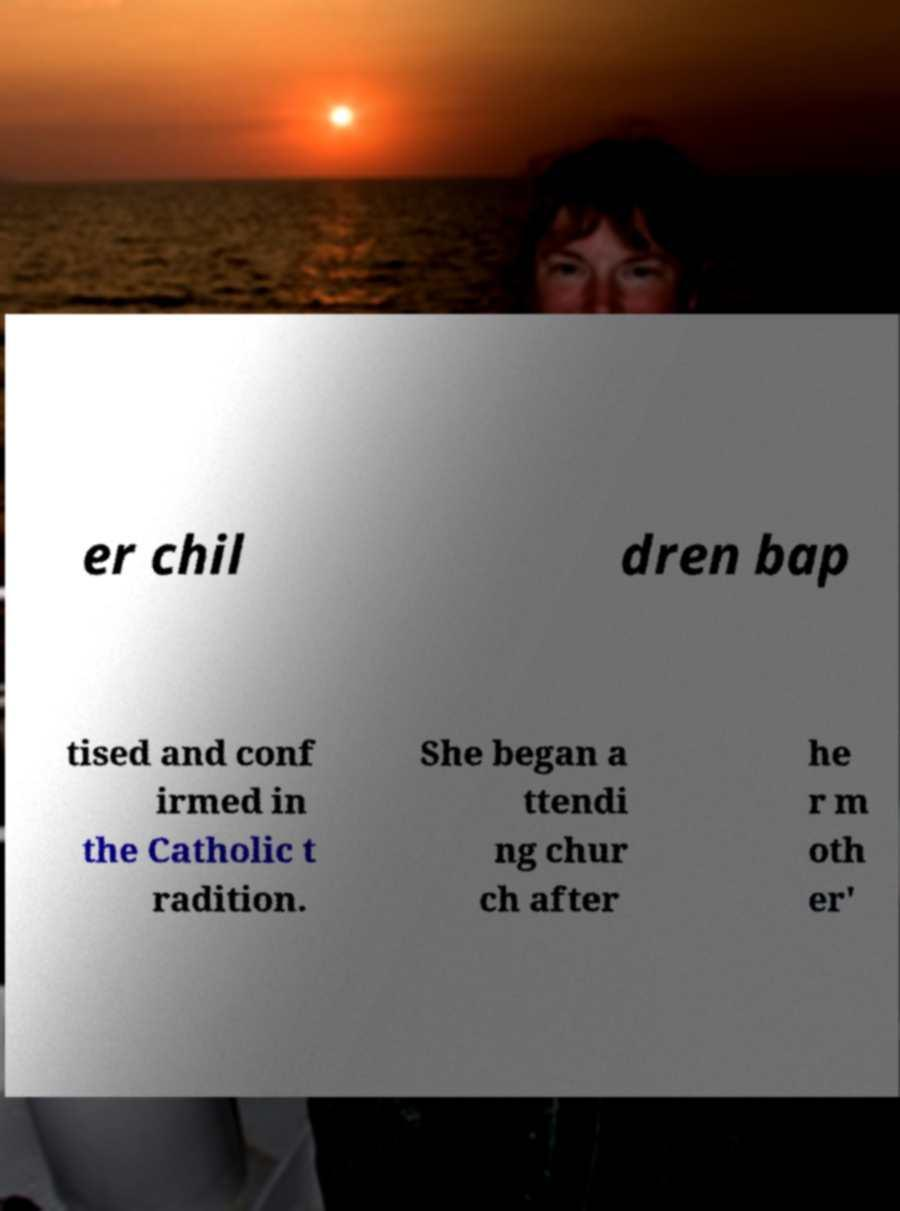Could you assist in decoding the text presented in this image and type it out clearly? er chil dren bap tised and conf irmed in the Catholic t radition. She began a ttendi ng chur ch after he r m oth er' 